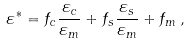Convert formula to latex. <formula><loc_0><loc_0><loc_500><loc_500>\varepsilon ^ { * } = f _ { c } \frac { \varepsilon _ { c } } { \varepsilon _ { m } } + f _ { s } \frac { \varepsilon _ { s } } { \varepsilon _ { m } } + f _ { m } \, ,</formula> 